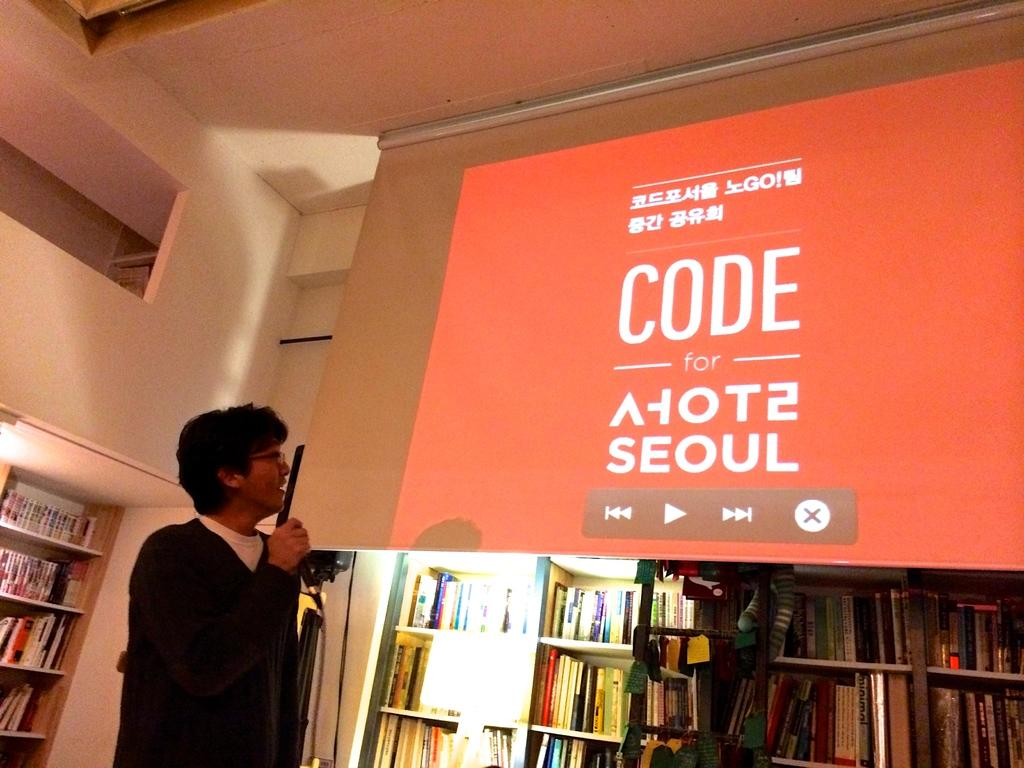<image>
Create a compact narrative representing the image presented. A man gives a speech about the projector screen which shows the Asian language and English writings as CODE for seoul 